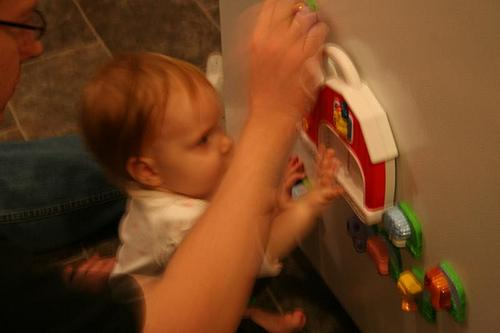What are the two using to play? Please explain your reasoning. refrigerator. They have magnets on the side of the fridge. 